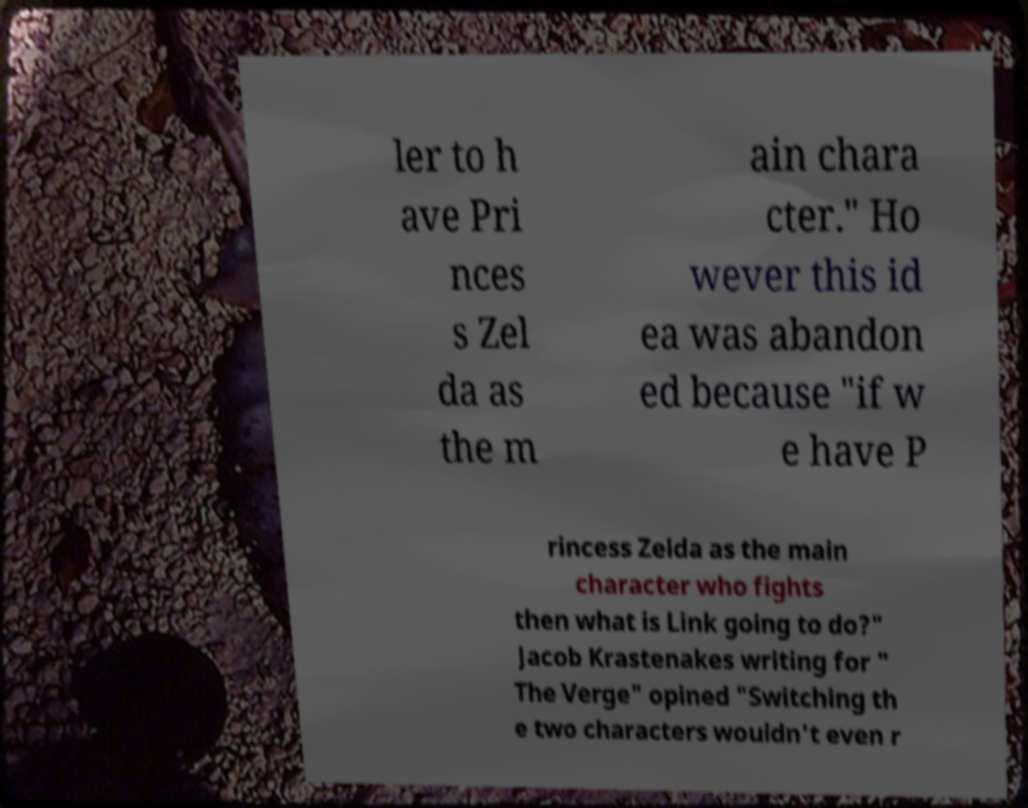There's text embedded in this image that I need extracted. Can you transcribe it verbatim? ler to h ave Pri nces s Zel da as the m ain chara cter." Ho wever this id ea was abandon ed because "if w e have P rincess Zelda as the main character who fights then what is Link going to do?" Jacob Krastenakes writing for " The Verge" opined "Switching th e two characters wouldn't even r 